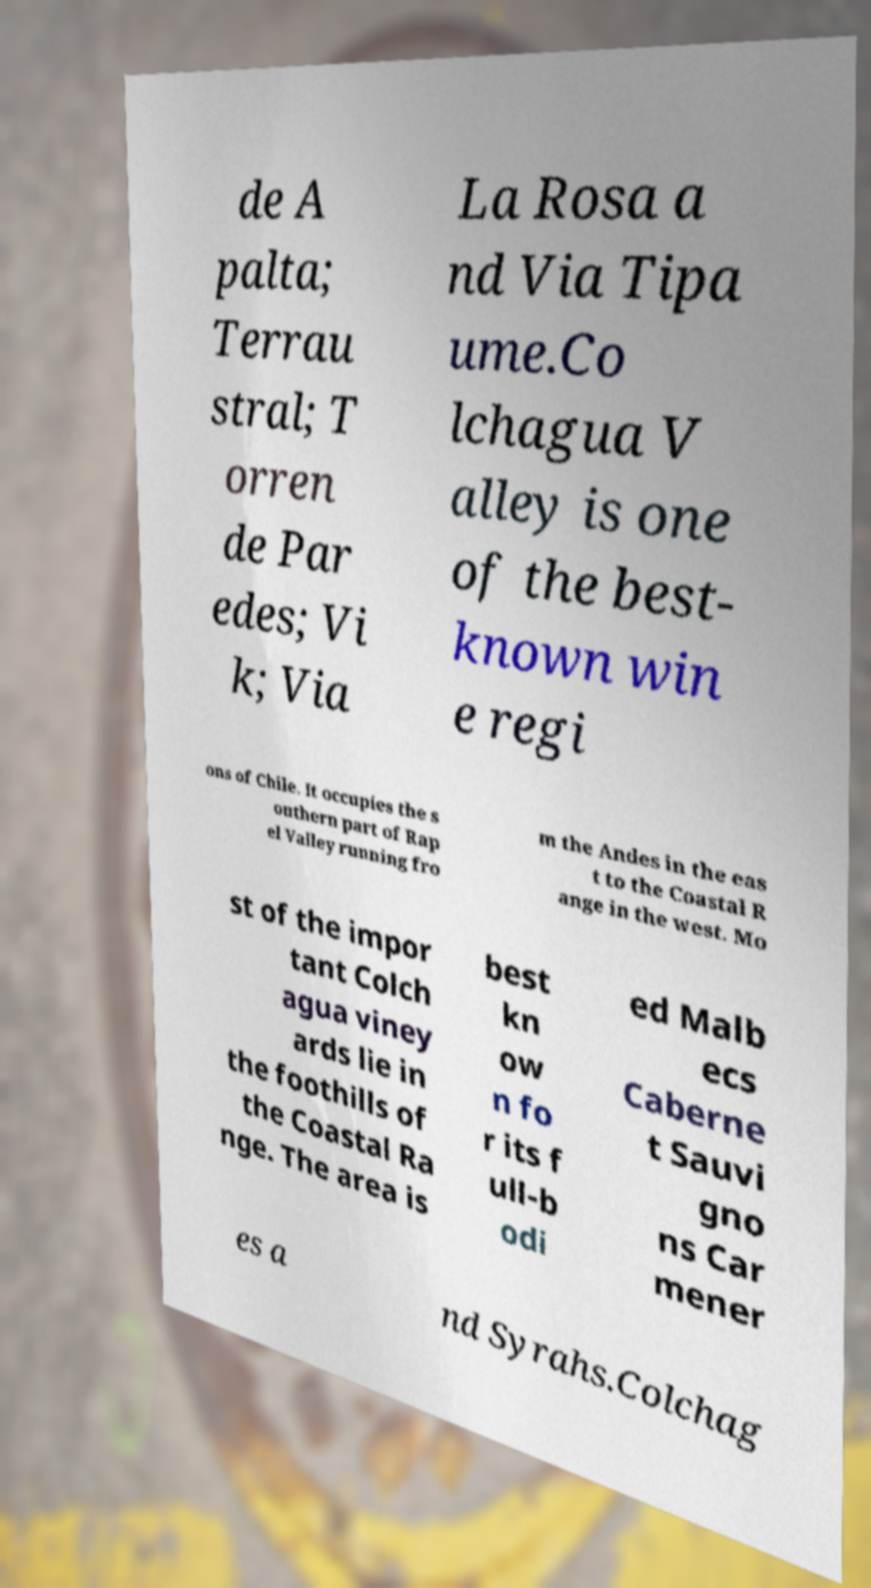There's text embedded in this image that I need extracted. Can you transcribe it verbatim? de A palta; Terrau stral; T orren de Par edes; Vi k; Via La Rosa a nd Via Tipa ume.Co lchagua V alley is one of the best- known win e regi ons of Chile. It occupies the s outhern part of Rap el Valley running fro m the Andes in the eas t to the Coastal R ange in the west. Mo st of the impor tant Colch agua viney ards lie in the foothills of the Coastal Ra nge. The area is best kn ow n fo r its f ull-b odi ed Malb ecs Caberne t Sauvi gno ns Car mener es a nd Syrahs.Colchag 